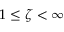<formula> <loc_0><loc_0><loc_500><loc_500>1 \leq \zeta < \infty</formula> 